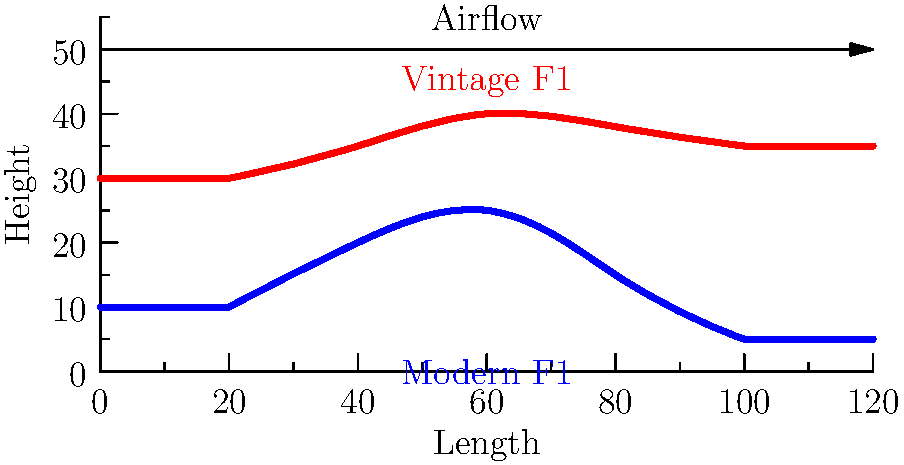Based on the side-view diagrams of vintage and modern Formula One cars shown above, which design exhibits a more pronounced focus on aerodynamic efficiency, and why? To answer this question, we need to analyze the profiles of both the vintage and modern F1 cars:

1. Vintage F1 car (red profile):
   - Higher overall profile
   - More rounded and bulbous shape
   - Less streamlined appearance

2. Modern F1 car (blue profile):
   - Lower overall profile
   - More angular and sleek shape
   - Clearly defined aerodynamic elements

3. Aerodynamic considerations:
   - Lower profiles reduce frontal area, decreasing air resistance
   - Smoother, more streamlined shapes reduce turbulence and drag
   - Angular elements can create controlled airflow for downforce

4. Comparison:
   - The modern F1 car has a significantly lower profile
   - Its shape is more angular and streamlined
   - It shows clear evidence of aerodynamic optimization

5. Historical context:
   - Vintage F1 cars were designed with less emphasis on aerodynamics
   - Modern F1 cars have benefited from decades of aerodynamic research and wind tunnel testing

Therefore, the modern F1 car design exhibits a more pronounced focus on aerodynamic efficiency due to its lower, more streamlined profile and clearly defined aerodynamic elements.
Answer: Modern F1 car, due to lower profile and streamlined shape. 